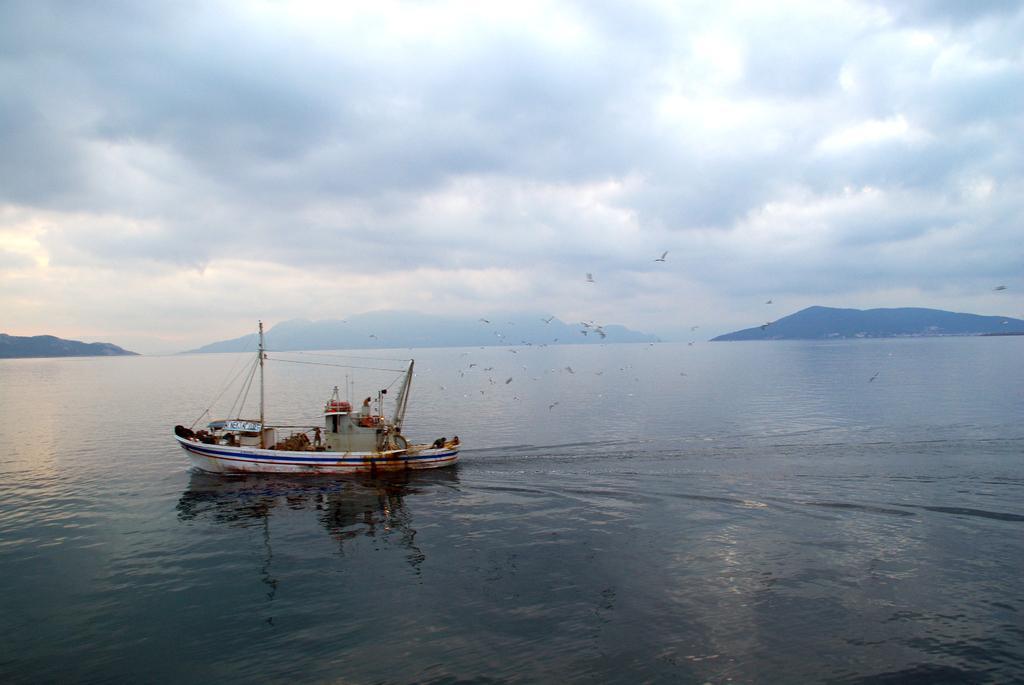In one or two sentences, can you explain what this image depicts? We can see ship above the water and we can see birds flying in the air. Background we can see hills and sky with clouds. 